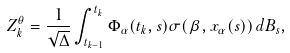<formula> <loc_0><loc_0><loc_500><loc_500>Z ^ { \theta } _ { k } = \frac { 1 } { \sqrt { \Delta } } \int ^ { t _ { k } } _ { t _ { k - 1 } } \Phi _ { \alpha } ( t _ { k } , s ) \sigma ( \beta , x _ { \alpha } ( s ) ) \, d B _ { s } ,</formula> 